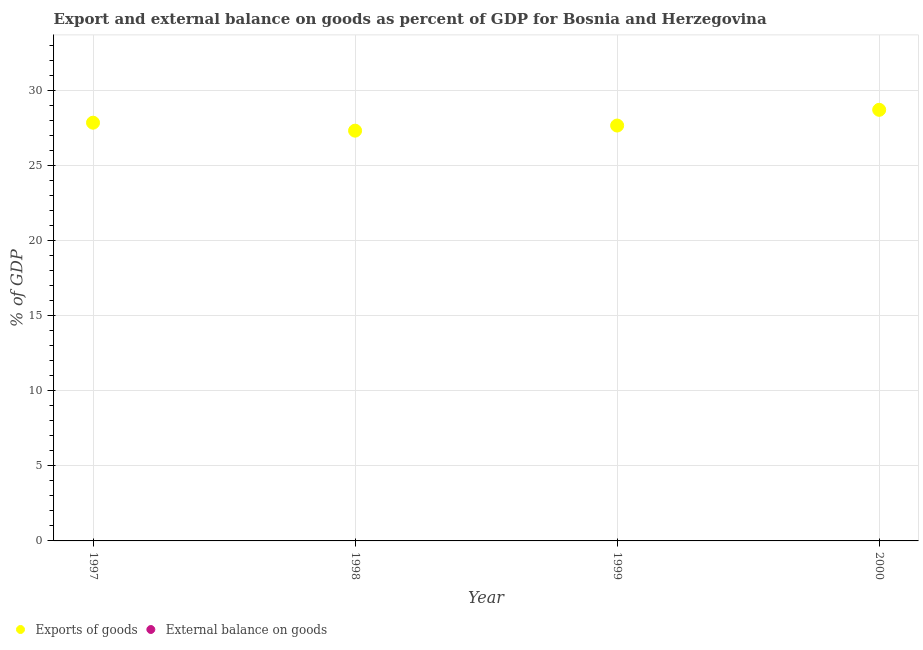What is the export of goods as percentage of gdp in 2000?
Your answer should be compact. 28.69. Across all years, what is the maximum export of goods as percentage of gdp?
Give a very brief answer. 28.69. Across all years, what is the minimum external balance on goods as percentage of gdp?
Offer a very short reply. 0. What is the difference between the export of goods as percentage of gdp in 1997 and that in 1999?
Your response must be concise. 0.19. What is the difference between the export of goods as percentage of gdp in 1997 and the external balance on goods as percentage of gdp in 1998?
Make the answer very short. 27.83. What is the average external balance on goods as percentage of gdp per year?
Your answer should be very brief. 0. What is the ratio of the export of goods as percentage of gdp in 1998 to that in 1999?
Your answer should be very brief. 0.99. What is the difference between the highest and the second highest export of goods as percentage of gdp?
Keep it short and to the point. 0.86. What is the difference between the highest and the lowest export of goods as percentage of gdp?
Keep it short and to the point. 1.39. In how many years, is the export of goods as percentage of gdp greater than the average export of goods as percentage of gdp taken over all years?
Provide a succinct answer. 1. Is the sum of the export of goods as percentage of gdp in 1998 and 1999 greater than the maximum external balance on goods as percentage of gdp across all years?
Ensure brevity in your answer.  Yes. Is the external balance on goods as percentage of gdp strictly less than the export of goods as percentage of gdp over the years?
Offer a very short reply. Yes. What is the difference between two consecutive major ticks on the Y-axis?
Provide a succinct answer. 5. Does the graph contain any zero values?
Ensure brevity in your answer.  Yes. Does the graph contain grids?
Your response must be concise. Yes. How many legend labels are there?
Offer a terse response. 2. How are the legend labels stacked?
Give a very brief answer. Horizontal. What is the title of the graph?
Offer a terse response. Export and external balance on goods as percent of GDP for Bosnia and Herzegovina. Does "National Tourists" appear as one of the legend labels in the graph?
Provide a short and direct response. No. What is the label or title of the X-axis?
Give a very brief answer. Year. What is the label or title of the Y-axis?
Your response must be concise. % of GDP. What is the % of GDP in Exports of goods in 1997?
Your answer should be compact. 27.83. What is the % of GDP of Exports of goods in 1998?
Make the answer very short. 27.3. What is the % of GDP of External balance on goods in 1998?
Provide a short and direct response. 0. What is the % of GDP of Exports of goods in 1999?
Your answer should be very brief. 27.64. What is the % of GDP in External balance on goods in 1999?
Your answer should be compact. 0. What is the % of GDP of Exports of goods in 2000?
Provide a short and direct response. 28.69. Across all years, what is the maximum % of GDP of Exports of goods?
Your answer should be compact. 28.69. Across all years, what is the minimum % of GDP of Exports of goods?
Keep it short and to the point. 27.3. What is the total % of GDP of Exports of goods in the graph?
Keep it short and to the point. 111.47. What is the difference between the % of GDP of Exports of goods in 1997 and that in 1998?
Make the answer very short. 0.53. What is the difference between the % of GDP of Exports of goods in 1997 and that in 1999?
Your answer should be compact. 0.19. What is the difference between the % of GDP of Exports of goods in 1997 and that in 2000?
Give a very brief answer. -0.86. What is the difference between the % of GDP of Exports of goods in 1998 and that in 1999?
Keep it short and to the point. -0.34. What is the difference between the % of GDP in Exports of goods in 1998 and that in 2000?
Your answer should be compact. -1.39. What is the difference between the % of GDP in Exports of goods in 1999 and that in 2000?
Your answer should be compact. -1.05. What is the average % of GDP of Exports of goods per year?
Your response must be concise. 27.87. What is the average % of GDP in External balance on goods per year?
Your answer should be very brief. 0. What is the ratio of the % of GDP in Exports of goods in 1997 to that in 1998?
Offer a very short reply. 1.02. What is the ratio of the % of GDP of Exports of goods in 1997 to that in 2000?
Your response must be concise. 0.97. What is the ratio of the % of GDP of Exports of goods in 1998 to that in 2000?
Your response must be concise. 0.95. What is the ratio of the % of GDP of Exports of goods in 1999 to that in 2000?
Your answer should be very brief. 0.96. What is the difference between the highest and the second highest % of GDP in Exports of goods?
Your answer should be compact. 0.86. What is the difference between the highest and the lowest % of GDP in Exports of goods?
Ensure brevity in your answer.  1.39. 